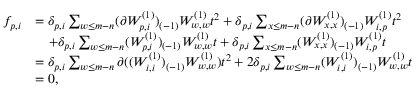<formula> <loc_0><loc_0><loc_500><loc_500>\begin{array} { r l } { f _ { p , i } } & { = \delta _ { p , i } \sum _ { w \leq m - n } ( \partial W _ { p , i } ^ { ( 1 ) } ) _ { ( - 1 ) } W _ { w , w } ^ { ( 1 ) } t ^ { 2 } + \delta _ { p , i } \sum _ { x \leq m - n } ( \partial W _ { x , x } ^ { ( 1 ) } ) _ { ( - 1 ) } W _ { i , p } ^ { ( 1 ) } t ^ { 2 } } \\ & { \quad + \delta _ { p , i } \sum _ { w \leq m - n } ( W _ { p , i } ^ { ( 1 ) } ) _ { ( - 1 ) } W _ { w , w } ^ { ( 1 ) } t + \delta _ { p , i } \sum _ { x \leq m - n } ( W _ { x , x } ^ { ( 1 ) } ) _ { ( - 1 ) } W _ { i , p } ^ { ( 1 ) } t } \\ & { = \delta _ { p , i } \sum _ { w \leq m - n } \partial ( ( W _ { i , i } ^ { ( 1 ) } ) _ { ( - 1 ) } W _ { w , w } ^ { ( 1 ) } ) t ^ { 2 } + 2 \delta _ { p , i } \sum _ { w \leq m - n } ( W _ { i , i } ^ { ( 1 ) } ) _ { ( - 1 ) } W _ { w , w } ^ { ( 1 ) } t } \\ & { = 0 , } \end{array}</formula> 